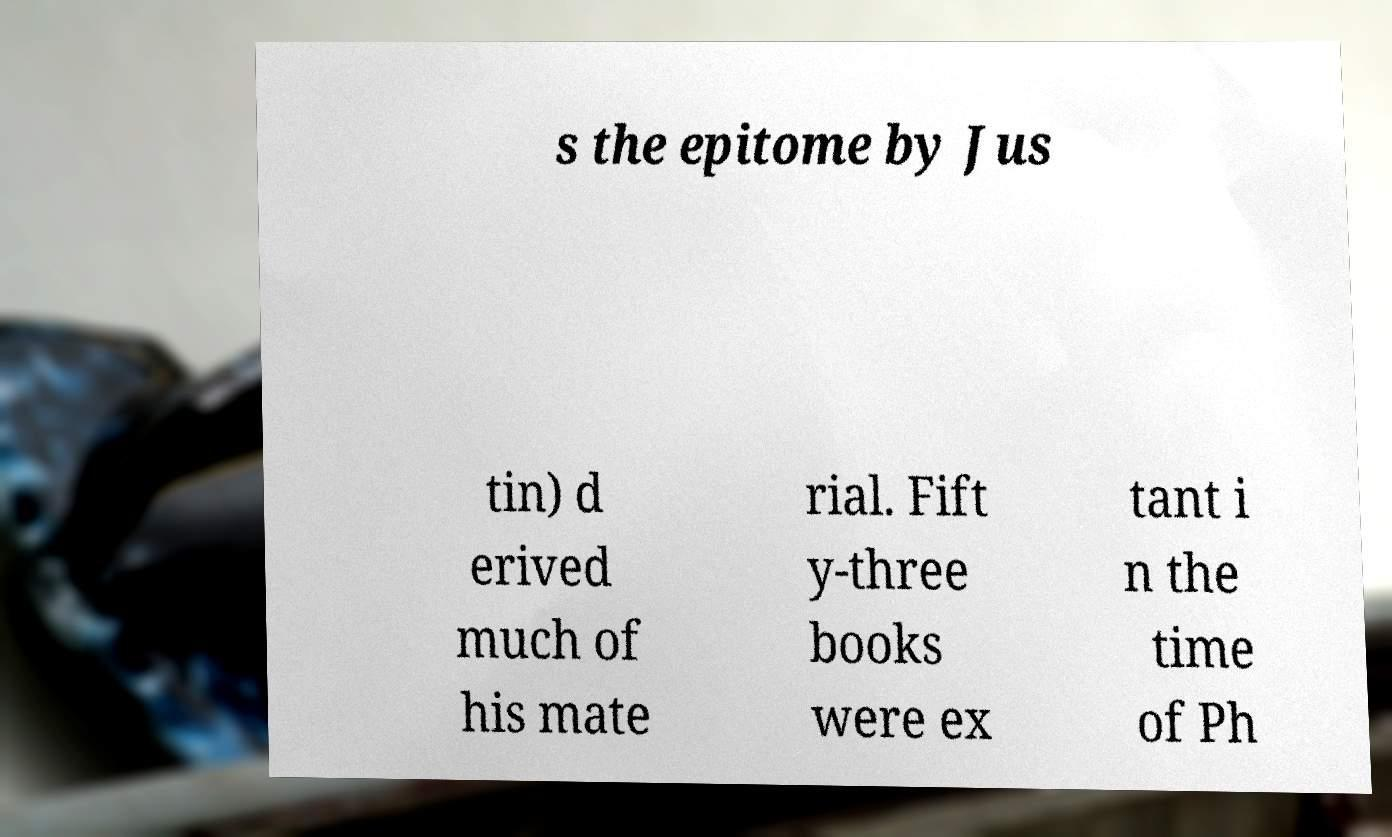Please identify and transcribe the text found in this image. s the epitome by Jus tin) d erived much of his mate rial. Fift y-three books were ex tant i n the time of Ph 